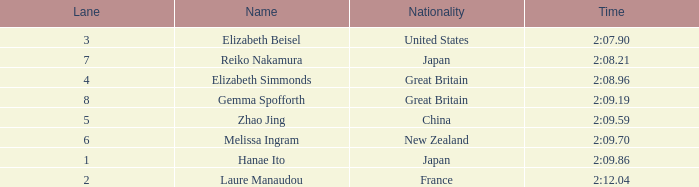What is the highest standing of laure manaudou? 8.0. 